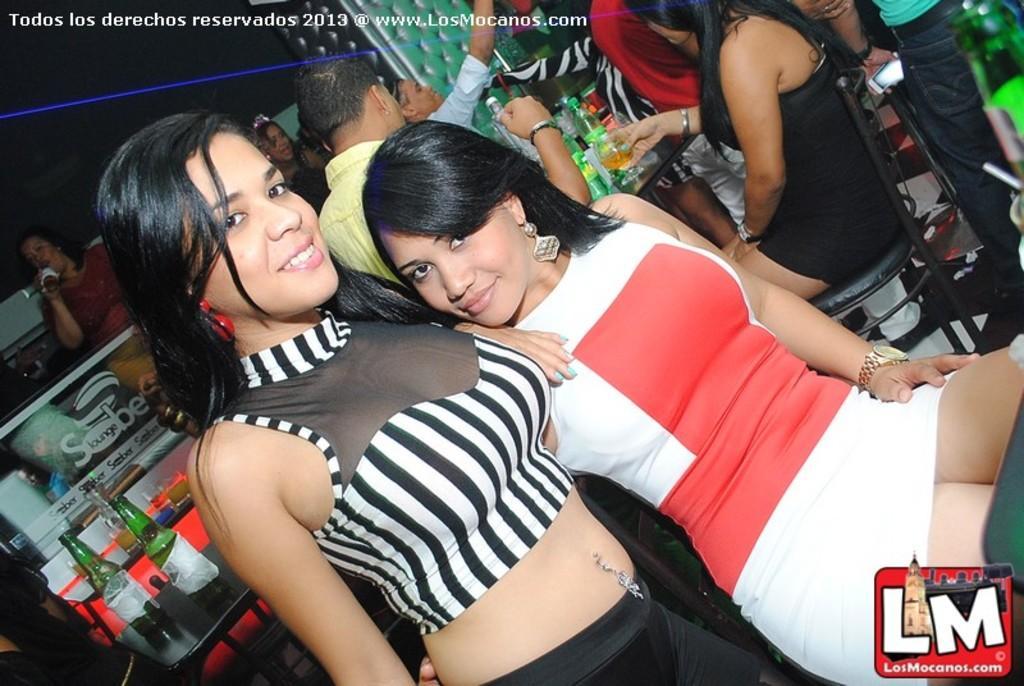Could you give a brief overview of what you see in this image? In this image there are group of persons standing and sitting. In the center there are bottles on the table which is black in colour and in the front there are woman standing and sitting having smile on their faces. In the background there is a woman drinking. 